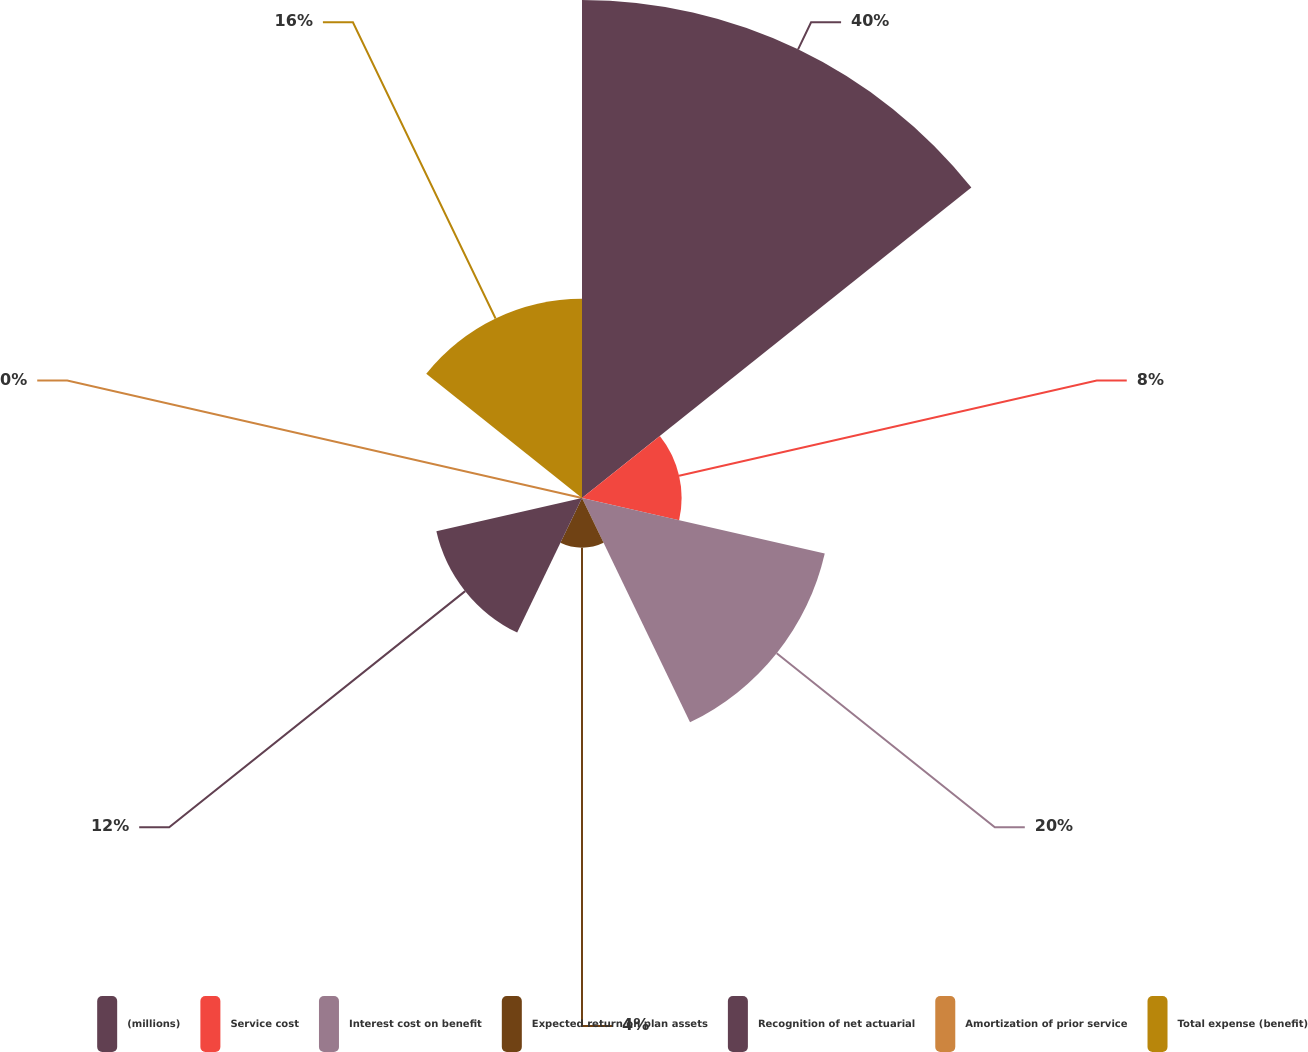Convert chart. <chart><loc_0><loc_0><loc_500><loc_500><pie_chart><fcel>(millions)<fcel>Service cost<fcel>Interest cost on benefit<fcel>Expected return on plan assets<fcel>Recognition of net actuarial<fcel>Amortization of prior service<fcel>Total expense (benefit)<nl><fcel>40.0%<fcel>8.0%<fcel>20.0%<fcel>4.0%<fcel>12.0%<fcel>0.0%<fcel>16.0%<nl></chart> 